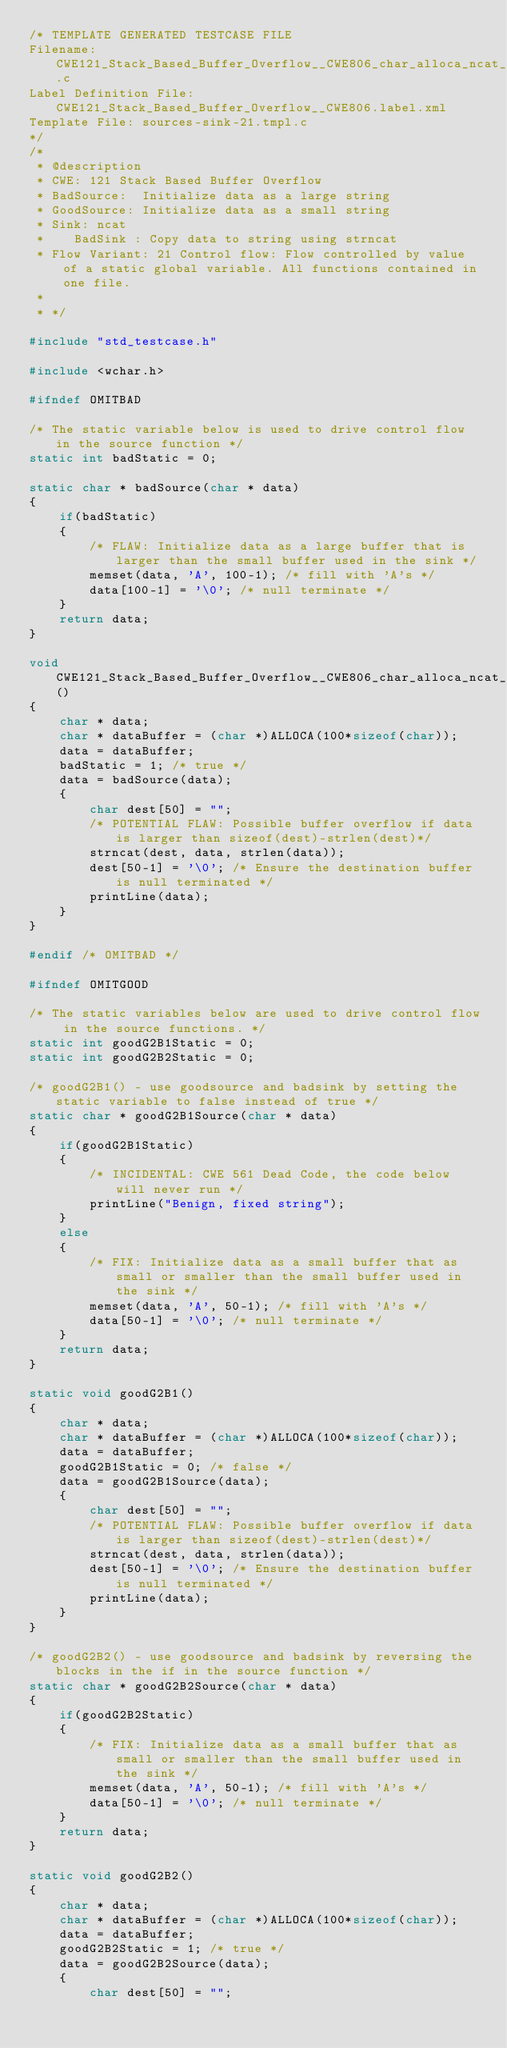Convert code to text. <code><loc_0><loc_0><loc_500><loc_500><_C_>/* TEMPLATE GENERATED TESTCASE FILE
Filename: CWE121_Stack_Based_Buffer_Overflow__CWE806_char_alloca_ncat_21.c
Label Definition File: CWE121_Stack_Based_Buffer_Overflow__CWE806.label.xml
Template File: sources-sink-21.tmpl.c
*/
/*
 * @description
 * CWE: 121 Stack Based Buffer Overflow
 * BadSource:  Initialize data as a large string
 * GoodSource: Initialize data as a small string
 * Sink: ncat
 *    BadSink : Copy data to string using strncat
 * Flow Variant: 21 Control flow: Flow controlled by value of a static global variable. All functions contained in one file.
 *
 * */

#include "std_testcase.h"

#include <wchar.h>

#ifndef OMITBAD

/* The static variable below is used to drive control flow in the source function */
static int badStatic = 0;

static char * badSource(char * data)
{
    if(badStatic)
    {
        /* FLAW: Initialize data as a large buffer that is larger than the small buffer used in the sink */
        memset(data, 'A', 100-1); /* fill with 'A's */
        data[100-1] = '\0'; /* null terminate */
    }
    return data;
}

void CWE121_Stack_Based_Buffer_Overflow__CWE806_char_alloca_ncat_21_bad()
{
    char * data;
    char * dataBuffer = (char *)ALLOCA(100*sizeof(char));
    data = dataBuffer;
    badStatic = 1; /* true */
    data = badSource(data);
    {
        char dest[50] = "";
        /* POTENTIAL FLAW: Possible buffer overflow if data is larger than sizeof(dest)-strlen(dest)*/
        strncat(dest, data, strlen(data));
        dest[50-1] = '\0'; /* Ensure the destination buffer is null terminated */
        printLine(data);
    }
}

#endif /* OMITBAD */

#ifndef OMITGOOD

/* The static variables below are used to drive control flow in the source functions. */
static int goodG2B1Static = 0;
static int goodG2B2Static = 0;

/* goodG2B1() - use goodsource and badsink by setting the static variable to false instead of true */
static char * goodG2B1Source(char * data)
{
    if(goodG2B1Static)
    {
        /* INCIDENTAL: CWE 561 Dead Code, the code below will never run */
        printLine("Benign, fixed string");
    }
    else
    {
        /* FIX: Initialize data as a small buffer that as small or smaller than the small buffer used in the sink */
        memset(data, 'A', 50-1); /* fill with 'A's */
        data[50-1] = '\0'; /* null terminate */
    }
    return data;
}

static void goodG2B1()
{
    char * data;
    char * dataBuffer = (char *)ALLOCA(100*sizeof(char));
    data = dataBuffer;
    goodG2B1Static = 0; /* false */
    data = goodG2B1Source(data);
    {
        char dest[50] = "";
        /* POTENTIAL FLAW: Possible buffer overflow if data is larger than sizeof(dest)-strlen(dest)*/
        strncat(dest, data, strlen(data));
        dest[50-1] = '\0'; /* Ensure the destination buffer is null terminated */
        printLine(data);
    }
}

/* goodG2B2() - use goodsource and badsink by reversing the blocks in the if in the source function */
static char * goodG2B2Source(char * data)
{
    if(goodG2B2Static)
    {
        /* FIX: Initialize data as a small buffer that as small or smaller than the small buffer used in the sink */
        memset(data, 'A', 50-1); /* fill with 'A's */
        data[50-1] = '\0'; /* null terminate */
    }
    return data;
}

static void goodG2B2()
{
    char * data;
    char * dataBuffer = (char *)ALLOCA(100*sizeof(char));
    data = dataBuffer;
    goodG2B2Static = 1; /* true */
    data = goodG2B2Source(data);
    {
        char dest[50] = "";</code> 